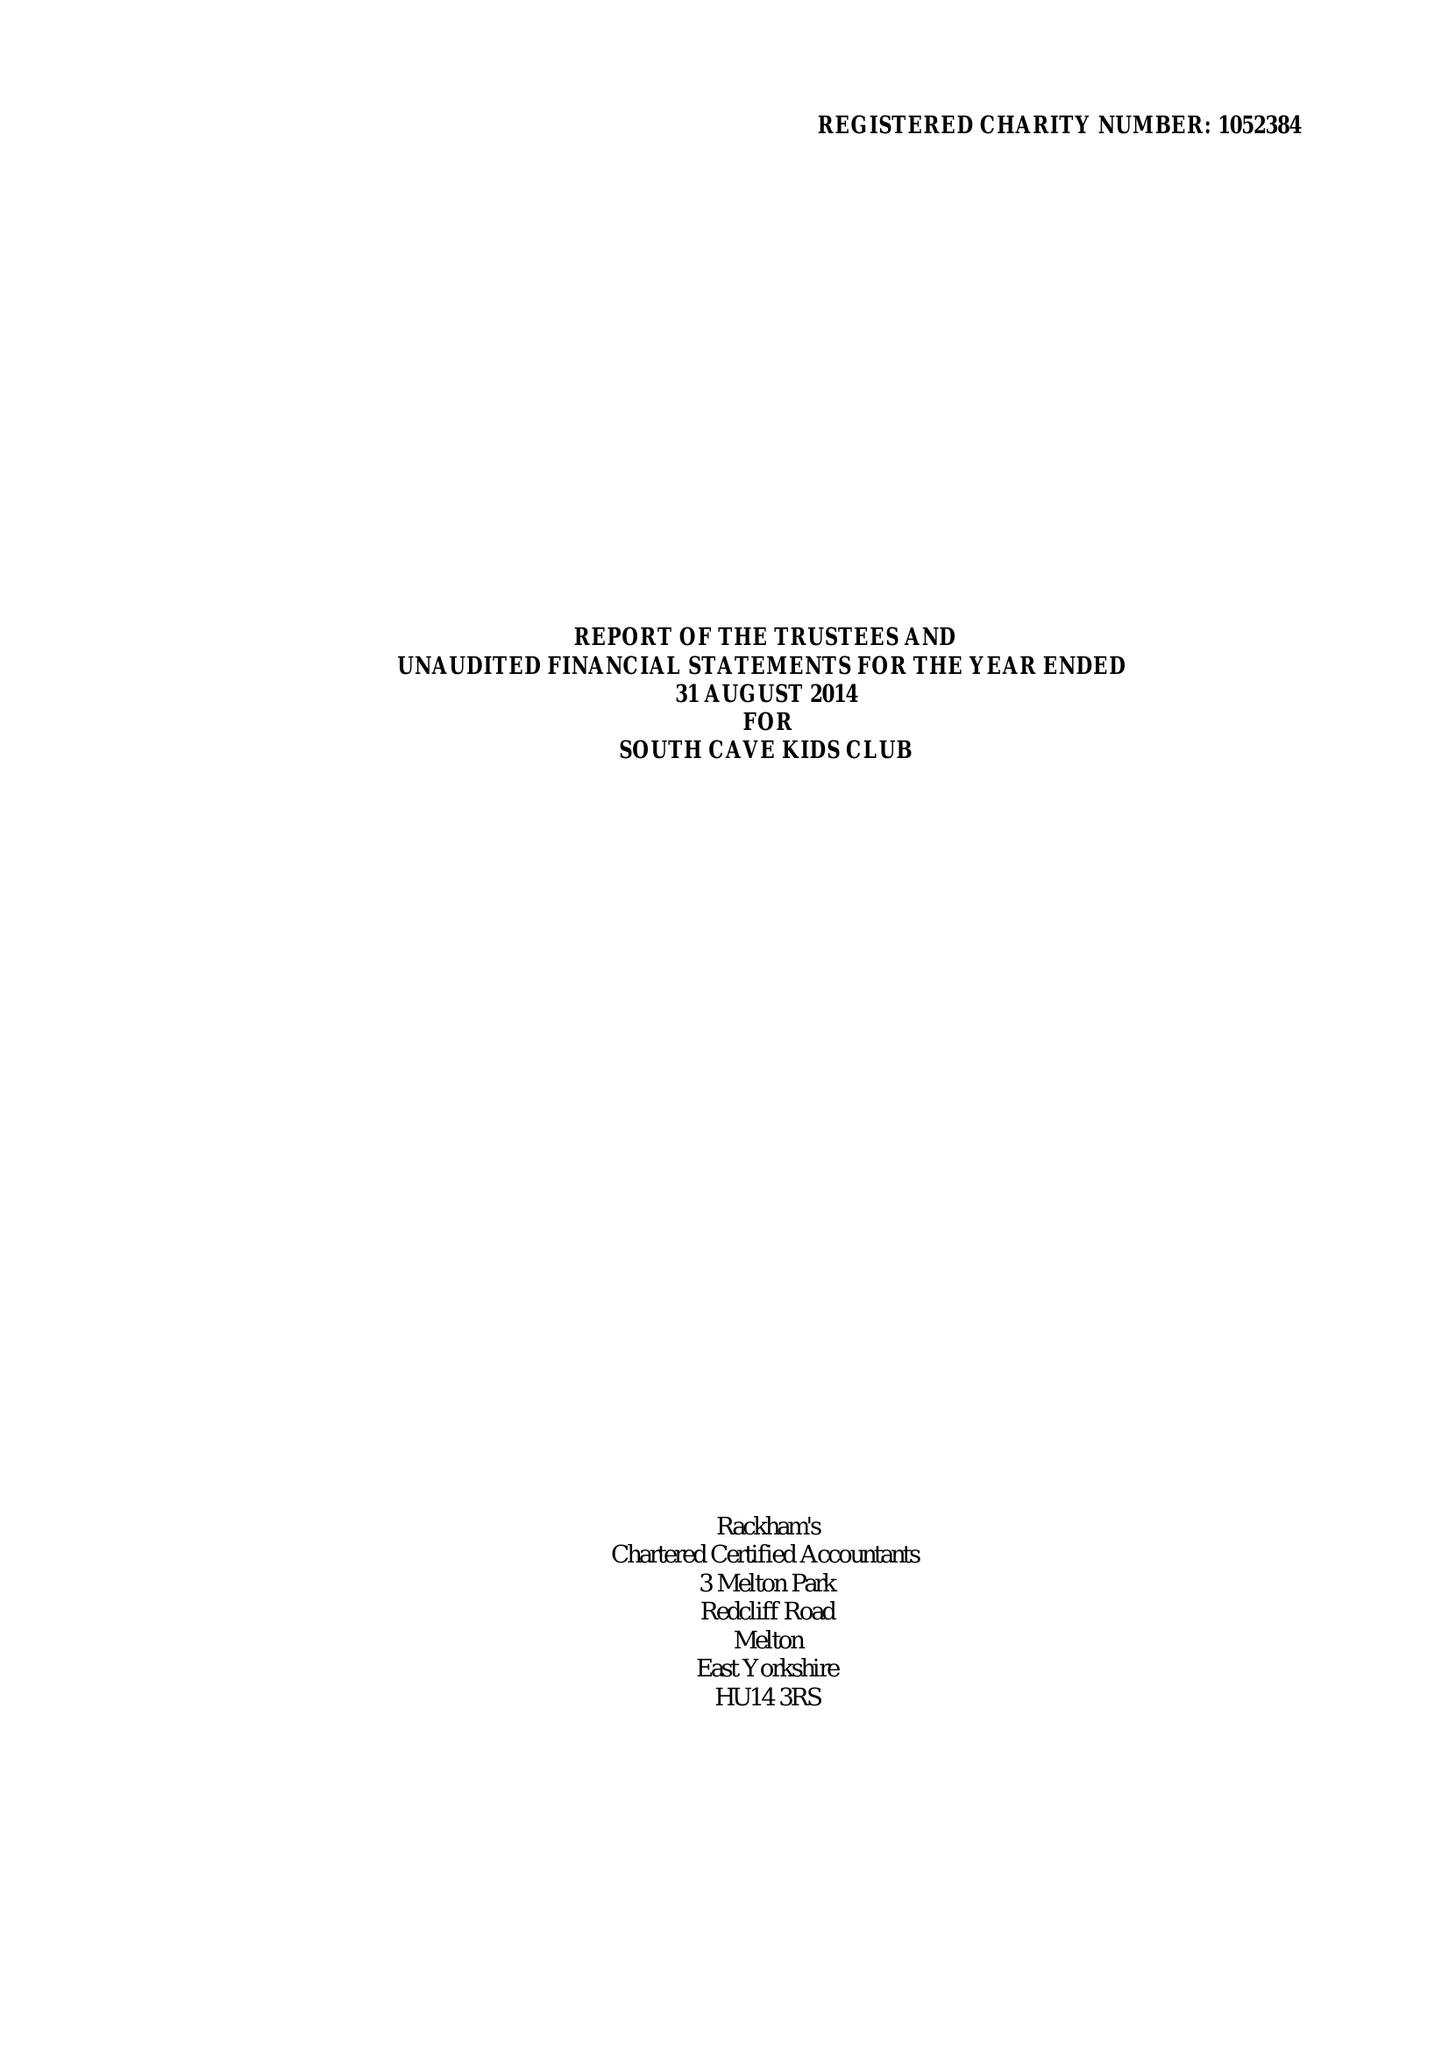What is the value for the charity_number?
Answer the question using a single word or phrase. 1052384 